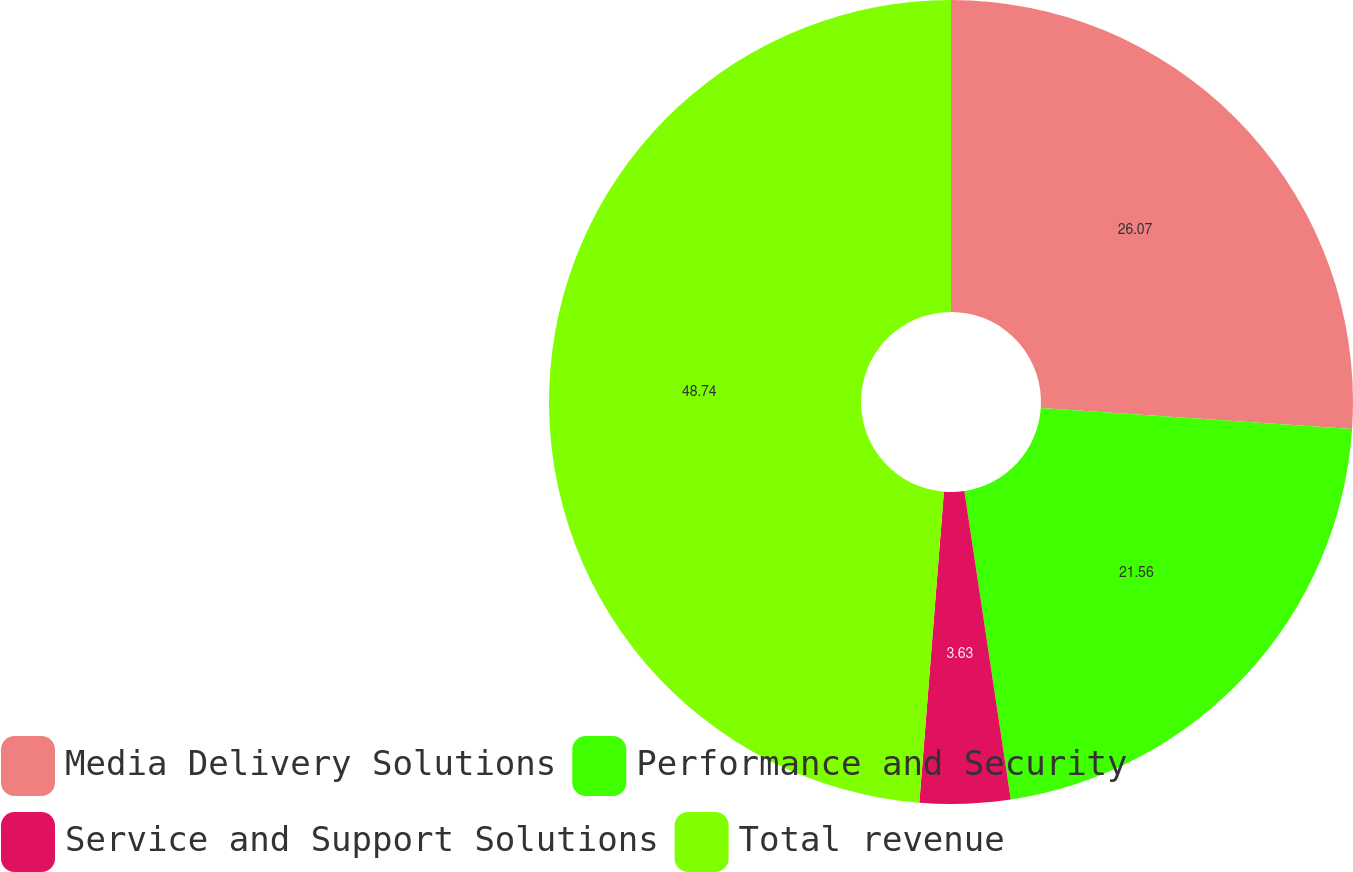Convert chart. <chart><loc_0><loc_0><loc_500><loc_500><pie_chart><fcel>Media Delivery Solutions<fcel>Performance and Security<fcel>Service and Support Solutions<fcel>Total revenue<nl><fcel>26.07%<fcel>21.56%<fcel>3.63%<fcel>48.75%<nl></chart> 